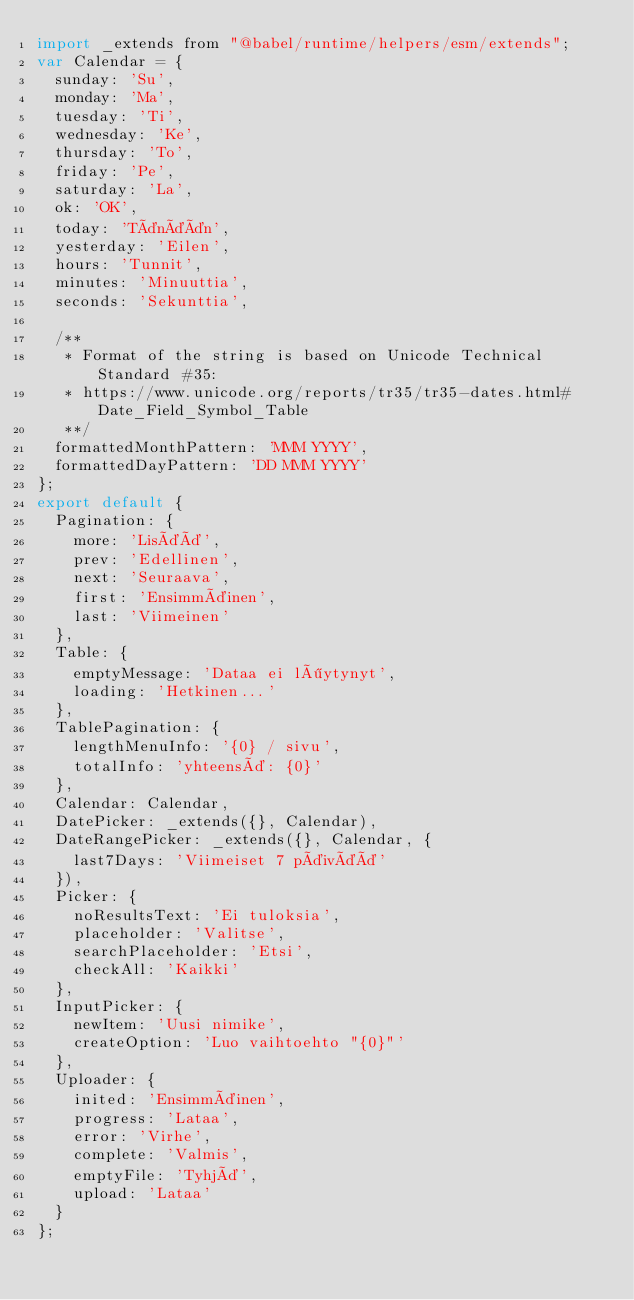<code> <loc_0><loc_0><loc_500><loc_500><_JavaScript_>import _extends from "@babel/runtime/helpers/esm/extends";
var Calendar = {
  sunday: 'Su',
  monday: 'Ma',
  tuesday: 'Ti',
  wednesday: 'Ke',
  thursday: 'To',
  friday: 'Pe',
  saturday: 'La',
  ok: 'OK',
  today: 'Tänään',
  yesterday: 'Eilen',
  hours: 'Tunnit',
  minutes: 'Minuuttia',
  seconds: 'Sekunttia',

  /**
   * Format of the string is based on Unicode Technical Standard #35:
   * https://www.unicode.org/reports/tr35/tr35-dates.html#Date_Field_Symbol_Table
   **/
  formattedMonthPattern: 'MMM YYYY',
  formattedDayPattern: 'DD MMM YYYY'
};
export default {
  Pagination: {
    more: 'Lisää',
    prev: 'Edellinen',
    next: 'Seuraava',
    first: 'Ensimmäinen',
    last: 'Viimeinen'
  },
  Table: {
    emptyMessage: 'Dataa ei löytynyt',
    loading: 'Hetkinen...'
  },
  TablePagination: {
    lengthMenuInfo: '{0} / sivu',
    totalInfo: 'yhteensä: {0}'
  },
  Calendar: Calendar,
  DatePicker: _extends({}, Calendar),
  DateRangePicker: _extends({}, Calendar, {
    last7Days: 'Viimeiset 7 päivää'
  }),
  Picker: {
    noResultsText: 'Ei tuloksia',
    placeholder: 'Valitse',
    searchPlaceholder: 'Etsi',
    checkAll: 'Kaikki'
  },
  InputPicker: {
    newItem: 'Uusi nimike',
    createOption: 'Luo vaihtoehto "{0}"'
  },
  Uploader: {
    inited: 'Ensimmäinen',
    progress: 'Lataa',
    error: 'Virhe',
    complete: 'Valmis',
    emptyFile: 'Tyhjä',
    upload: 'Lataa'
  }
};</code> 